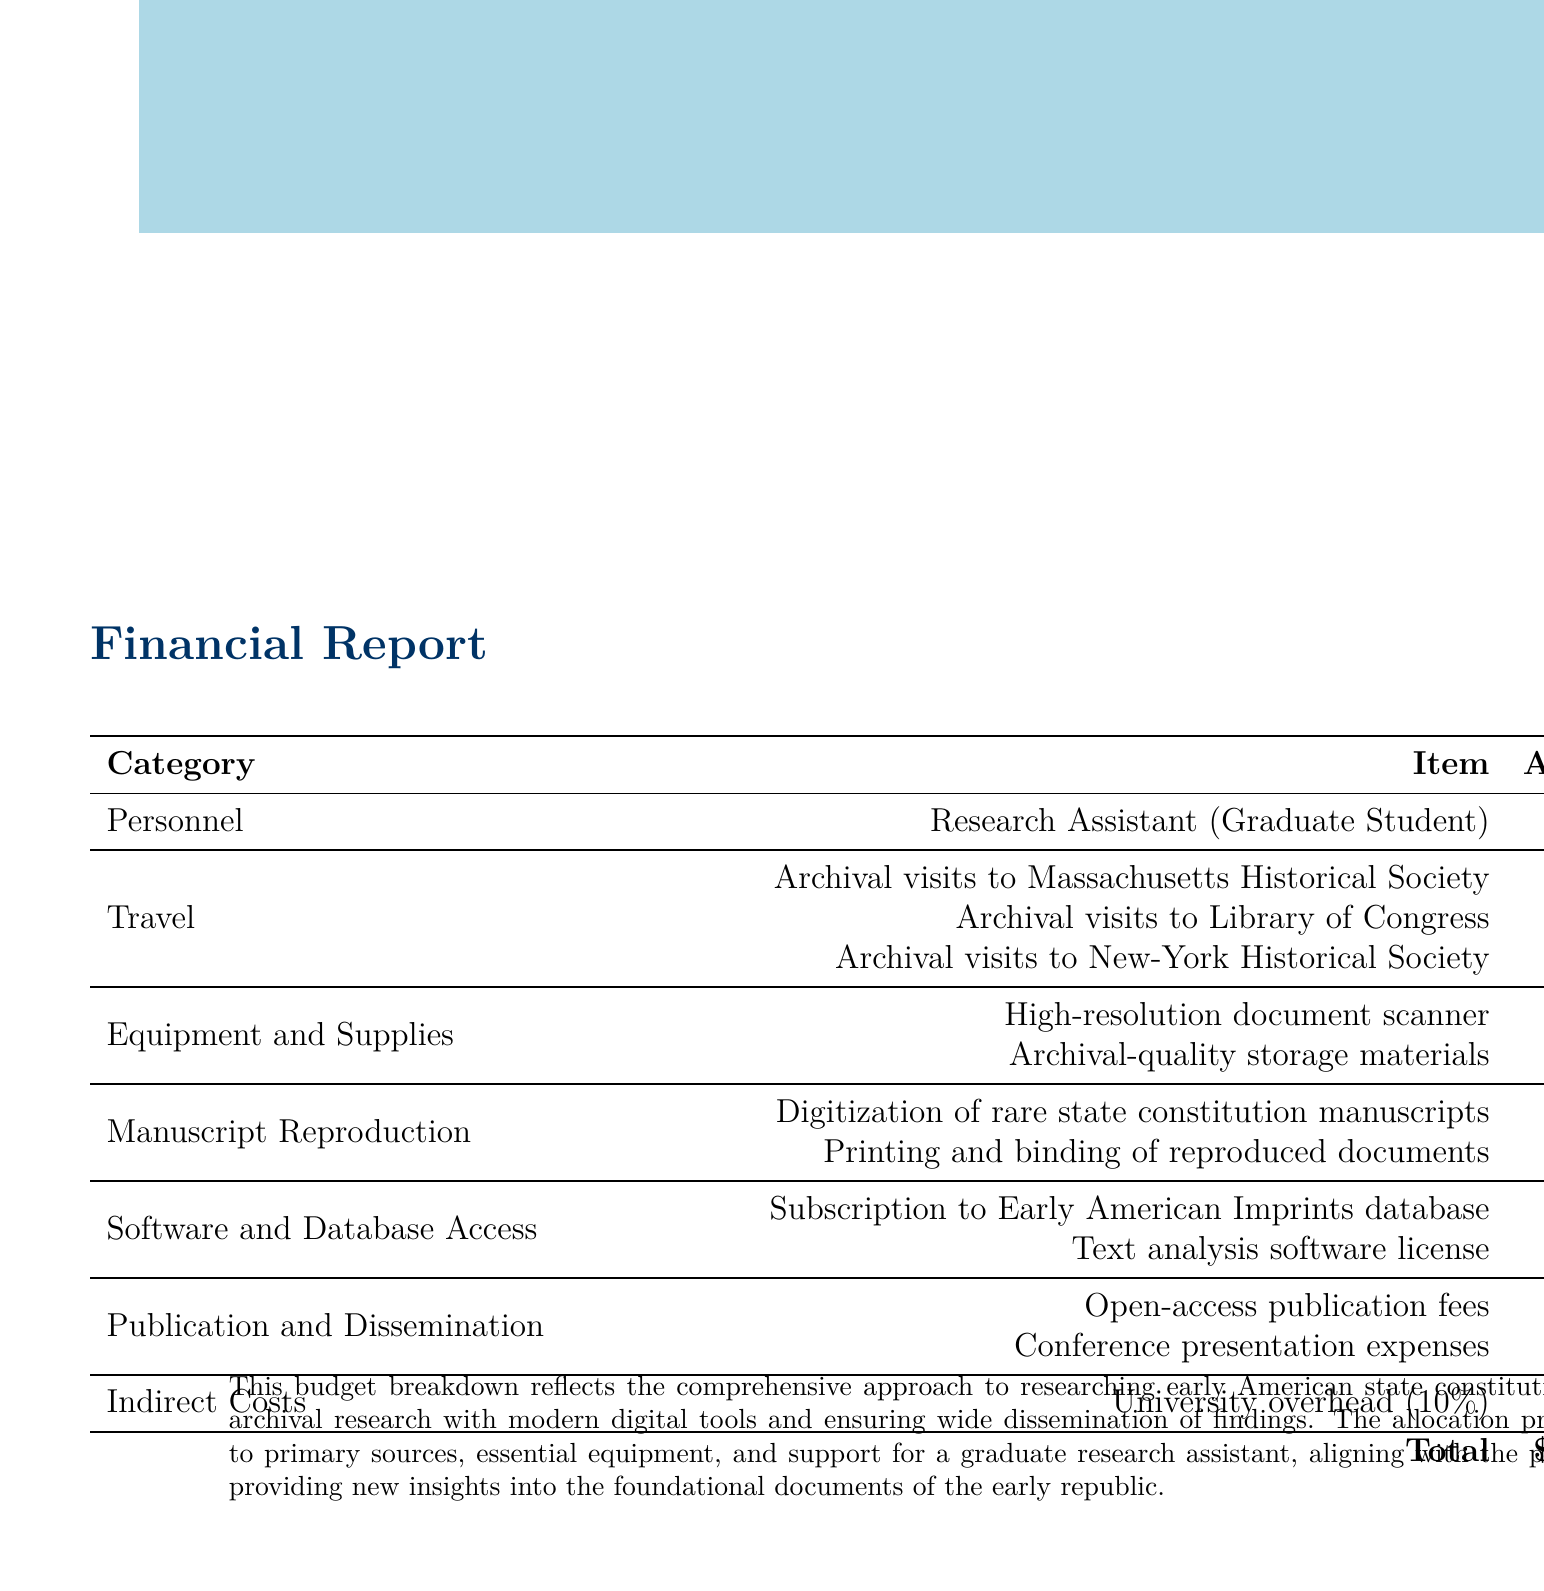What is the project title? The project title is stated clearly at the beginning of the document.
Answer: Early American State Constitutions: A Comparative Analysis (1776-1800) Who is the principal investigator? The principal investigator's name is provided in the heading section of the document.
Answer: Dr. Elizabeth Chambers What is the budget for manuscript reproduction? The budget for manuscript reproduction includes two items, and their total is calculated from the document.
Answer: $6,500 How much is allocated for archival visits to the Library of Congress? The amount for archival visits to the Library of Congress is specifically listed under the travel category.
Answer: $3,000 What percentage of the budget is allocated for university overhead? The indirect costs section specifies the overhead percentage for the university.
Answer: 10% How many items are listed under the travel category? The travel category contains multiple items, and the number of items can be counted from the document.
Answer: 3 What is the total budget amount? The total budget is provided at the beginning and confirmed by the summed total at the end of the expenses table.
Answer: $45,000 What is the amount for the open-access publication fees? The amount for open-access publication fees is specified under the publication and dissemination category.
Answer: $3,000 Which database subscription is included in the budget? The document specifically names the subscription to a database within the software and database access section.
Answer: Early American Imprints database 